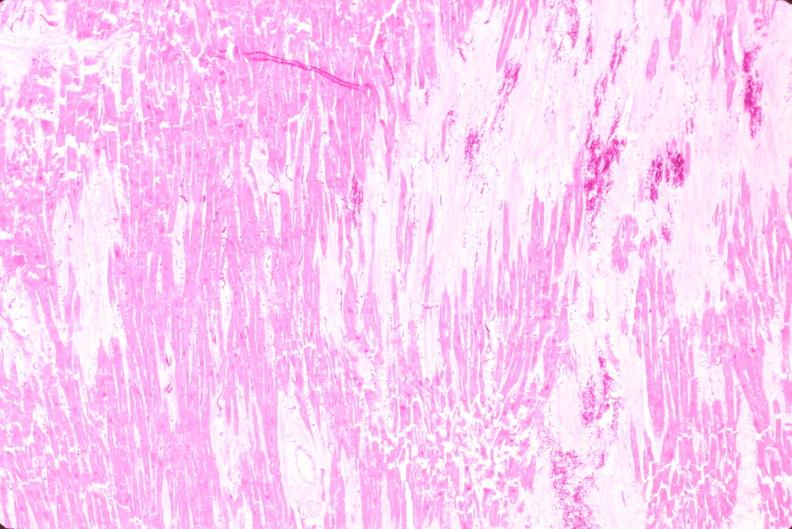s polycystic disease present?
Answer the question using a single word or phrase. No 